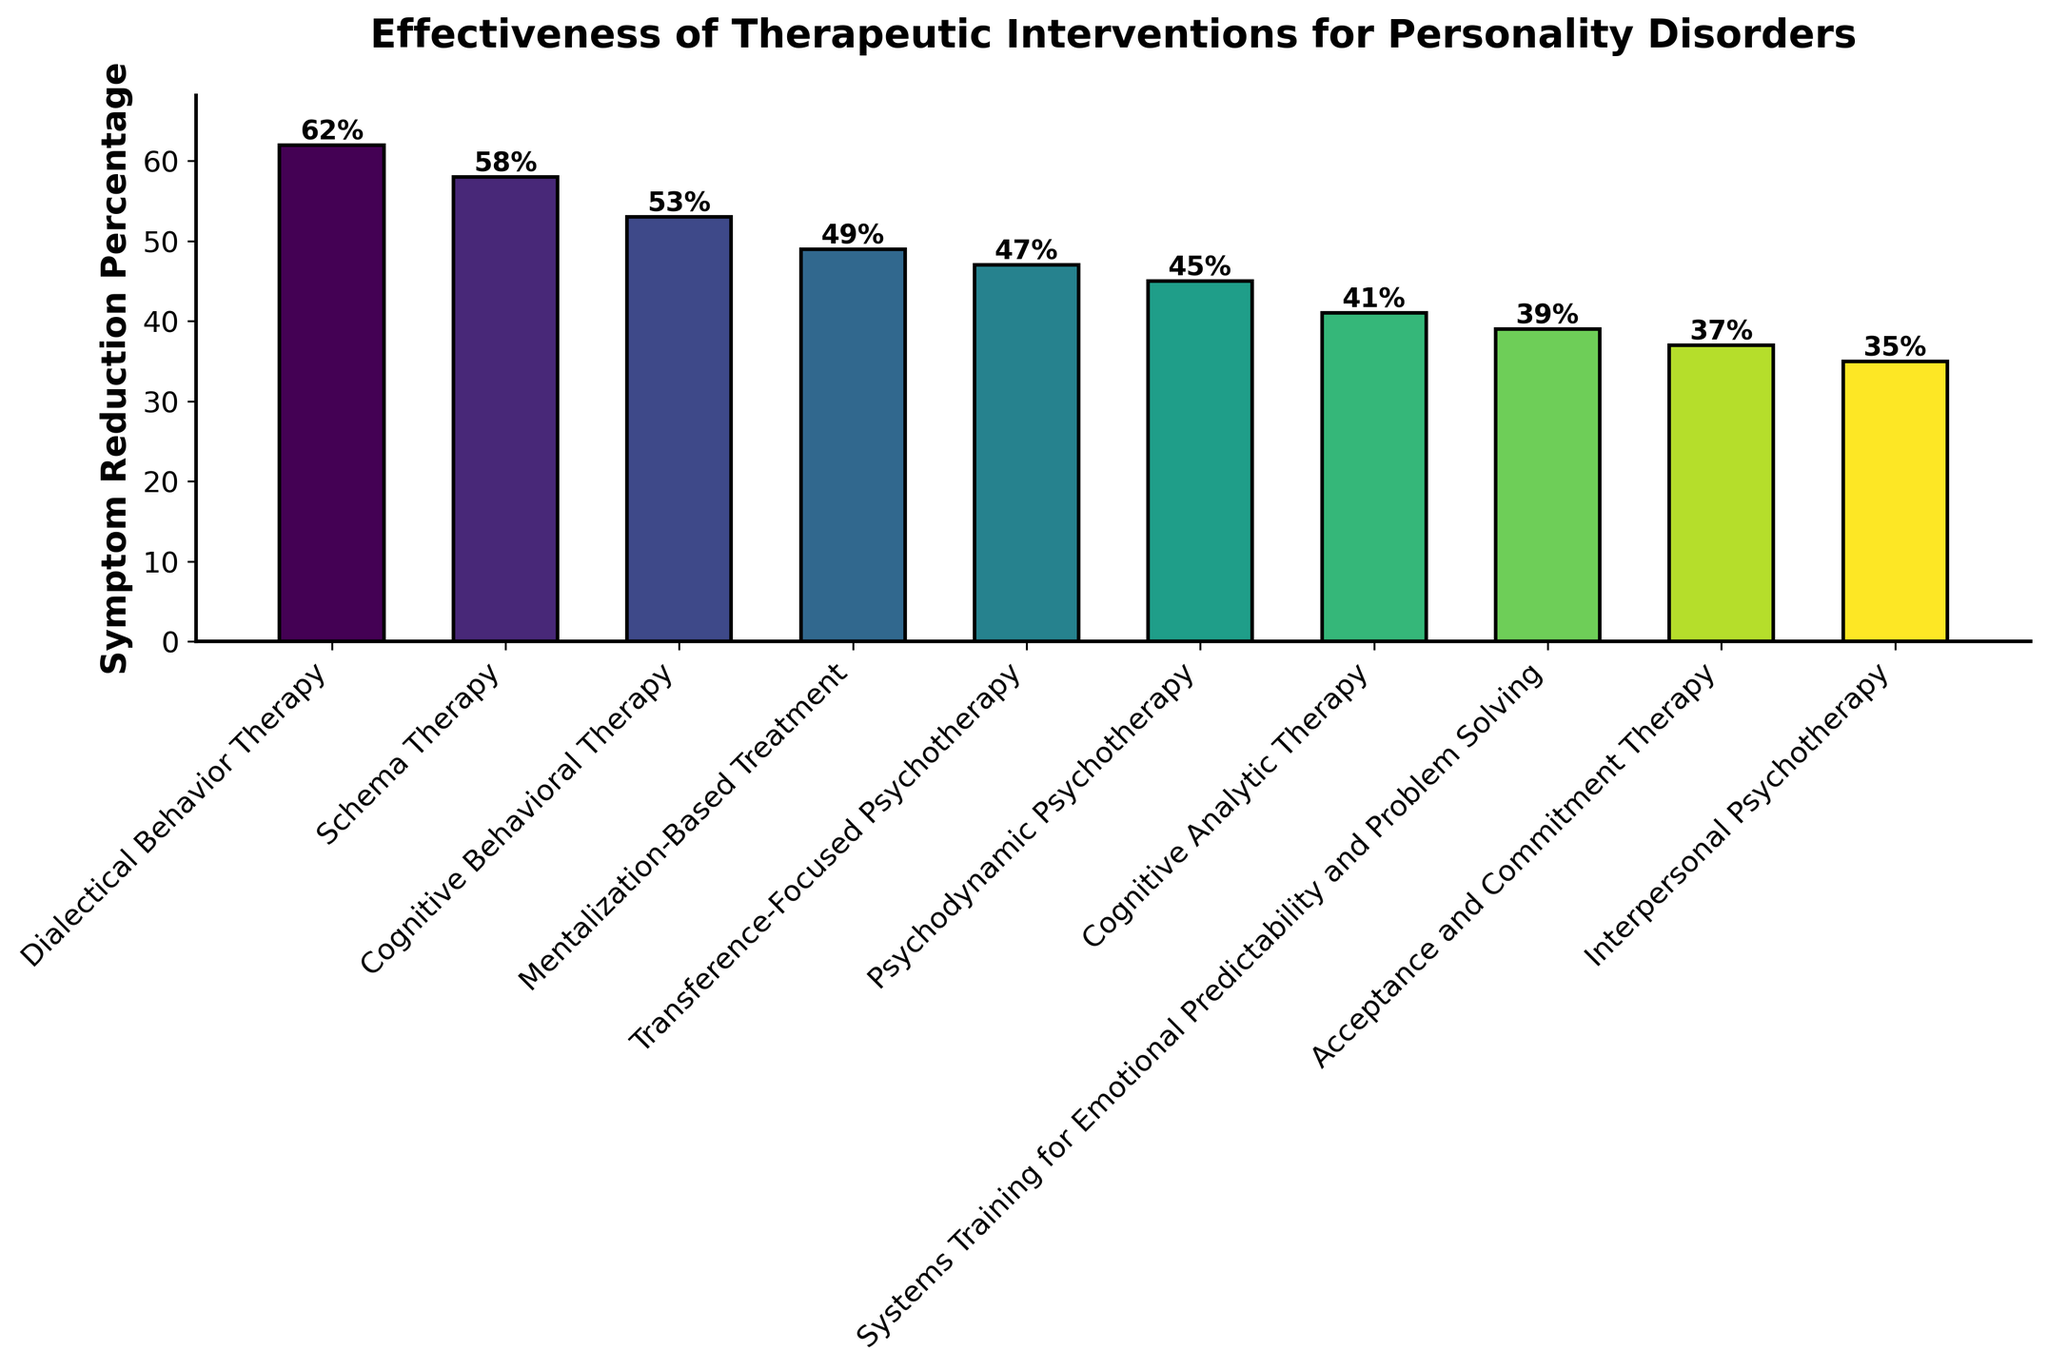Which therapeutic intervention shows the highest symptom reduction percentage? The highest bar on the chart represents the intervention with the highest symptom reduction percentage. The tallest bar corresponds to Dialectical Behavior Therapy.
Answer: Dialectical Behavior Therapy Which three therapeutic interventions show the lowest symptom reduction percentages? The bars that are the shortest correspond to the interventions with the lowest symptom reduction percentages. The three shortest bars represent Acceptance and Commitment Therapy, Interpersonal Psychotherapy, and Systems Training for Emotional Predictability and Problem Solving.
Answer: Acceptance and Commitment Therapy, Interpersonal Psychotherapy, Systems Training for Emotional Predictability and Problem Solving What is the range of symptom reduction percentages shown in the chart? The range can be found by subtracting the smallest symptom reduction percentage from the largest. The largest percentage is 62% (Dialectical Behavior Therapy) and the smallest is 35% (Interpersonal Psychotherapy). The range is 62% - 35% = 27%.
Answer: 27% Which therapeutic interventions have a symptom reduction percentage greater than 50%? By inspecting the bars that extend above the 50% mark, we can identify the interventions. These are Dialectical Behavior Therapy, Schema Therapy, and Cognitive Behavioral Therapy.
Answer: Dialectical Behavior Therapy, Schema Therapy, Cognitive Behavioral Therapy How many therapeutic interventions have a symptom reduction percentage between 40% and 60%? By counting the bars whose heights fall within the 40% to 60% range, we identify that there are six interventions: Schema Therapy, Cognitive Behavioral Therapy, Mentalization-Based Treatment, Transference-Focused Psychotherapy, Psychodynamic Psychotherapy, and Cognitive Analytic Therapy.
Answer: 6 What is the average symptom reduction percentage for the interventions shown? The average is calculated by summing all symptom reduction percentages and dividing by the number of interventions. The percentages are 62, 58, 53, 49, 47, 45, 41, 39, 37, and 35. Summing these gives 466, and dividing by 10 results in an average of 46.6%.
Answer: 46.6% By how many percentage points does Dialectical Behavior Therapy exceed Interpersonal Psychotherapy in symptom reduction? Subtract the symptom reduction percentage of Interpersonal Psychotherapy from that of Dialectical Behavior Therapy: 62% - 35% = 27%.
Answer: 27% Which therapeutic intervention shows a symptom reduction less than Psychodynamic Psychotherapy but more than Acceptance and Commitment Therapy? By identifying the bars that correspond to percentages less than 45% (Psychodynamic Psychotherapy) and more than 37% (Acceptance and Commitment Therapy), we find that Cognitive Analytic Therapy (41%) meets this criterion.
Answer: Cognitive Analytic Therapy What is the total combined symptom reduction percentage for Schema Therapy and Mentalization-Based Treatment? Add the symptom reduction percentages for Schema Therapy (58%) and Mentalization-Based Treatment (49%): 58% + 49% = 107%.
Answer: 107% What is the median symptom reduction percentage? To find the median, list the percentages in ascending order: 35%, 37%, 39%, 41%, 45%, 47%, 49%, 53%, 58%, 62%. Since there are 10 values, the median is the average of the 5th and 6th values: (45% + 47%)/2 = 46%.
Answer: 46% 